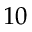<formula> <loc_0><loc_0><loc_500><loc_500>1 0</formula> 